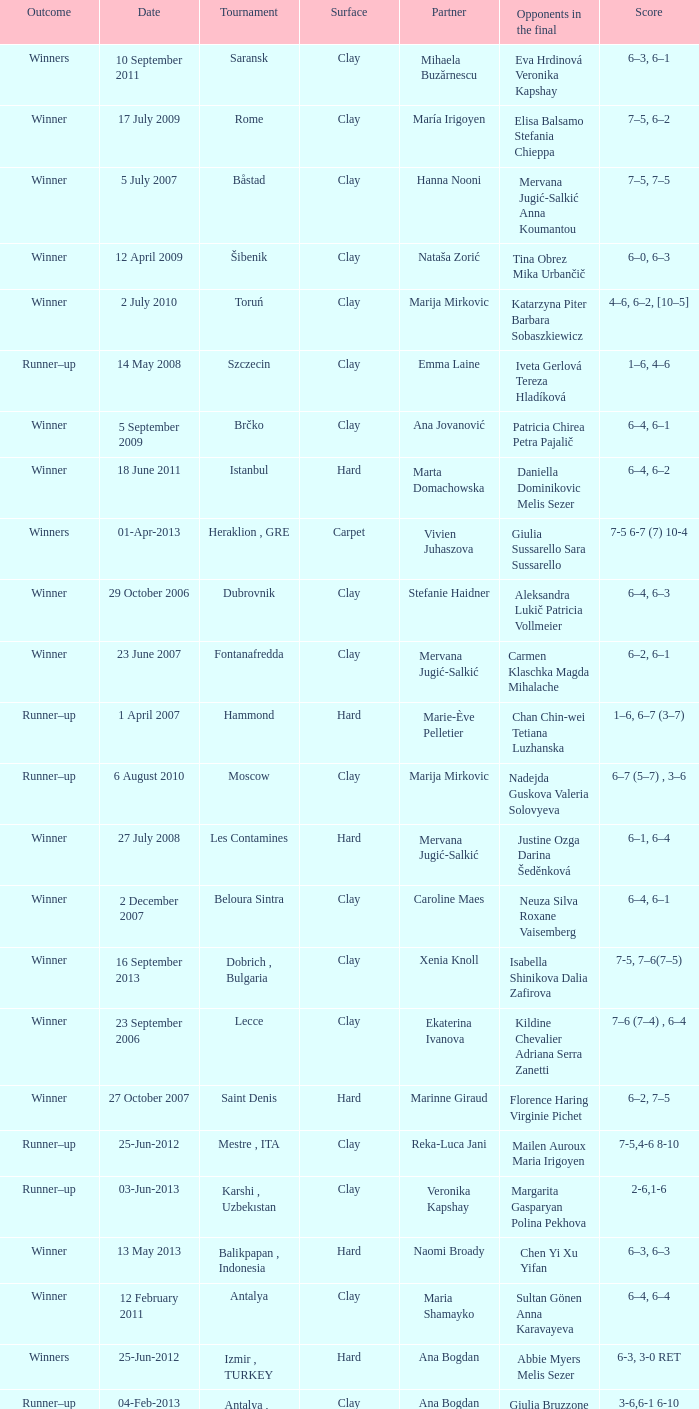Who were the opponents in the final at Noida? Kelly Anderson Chanelle Scheepers. 